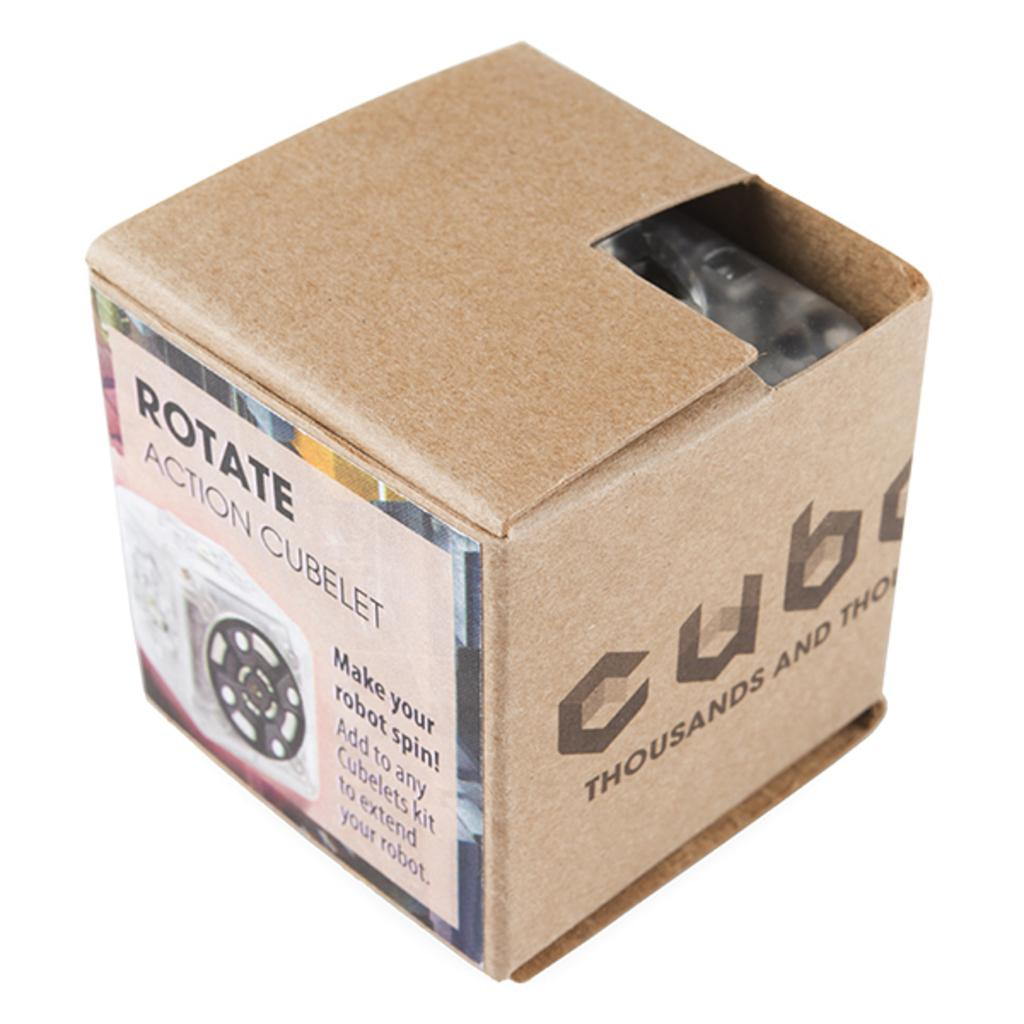<image>
Write a terse but informative summary of the picture. A box that contains a rotate action cubelet. 